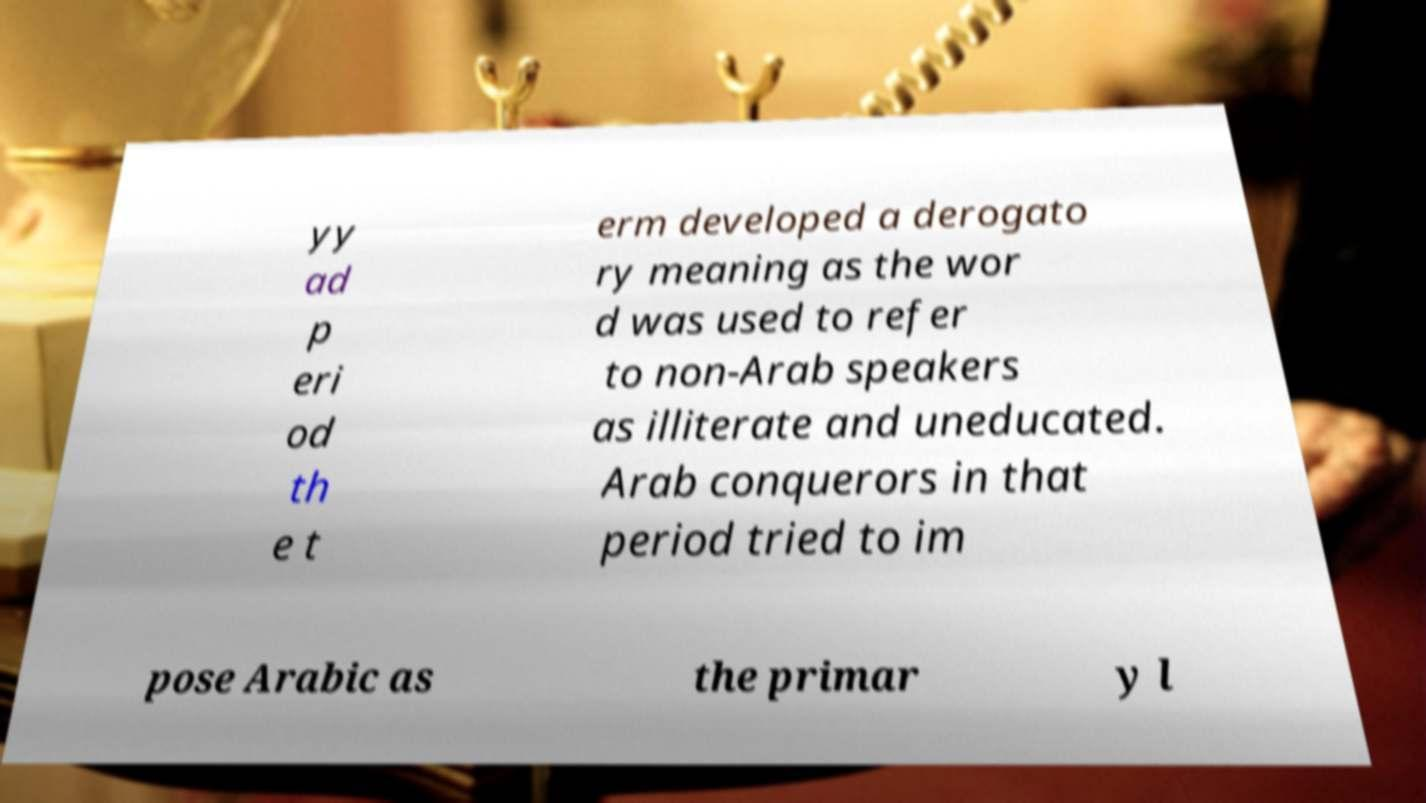What messages or text are displayed in this image? I need them in a readable, typed format. yy ad p eri od th e t erm developed a derogato ry meaning as the wor d was used to refer to non-Arab speakers as illiterate and uneducated. Arab conquerors in that period tried to im pose Arabic as the primar y l 